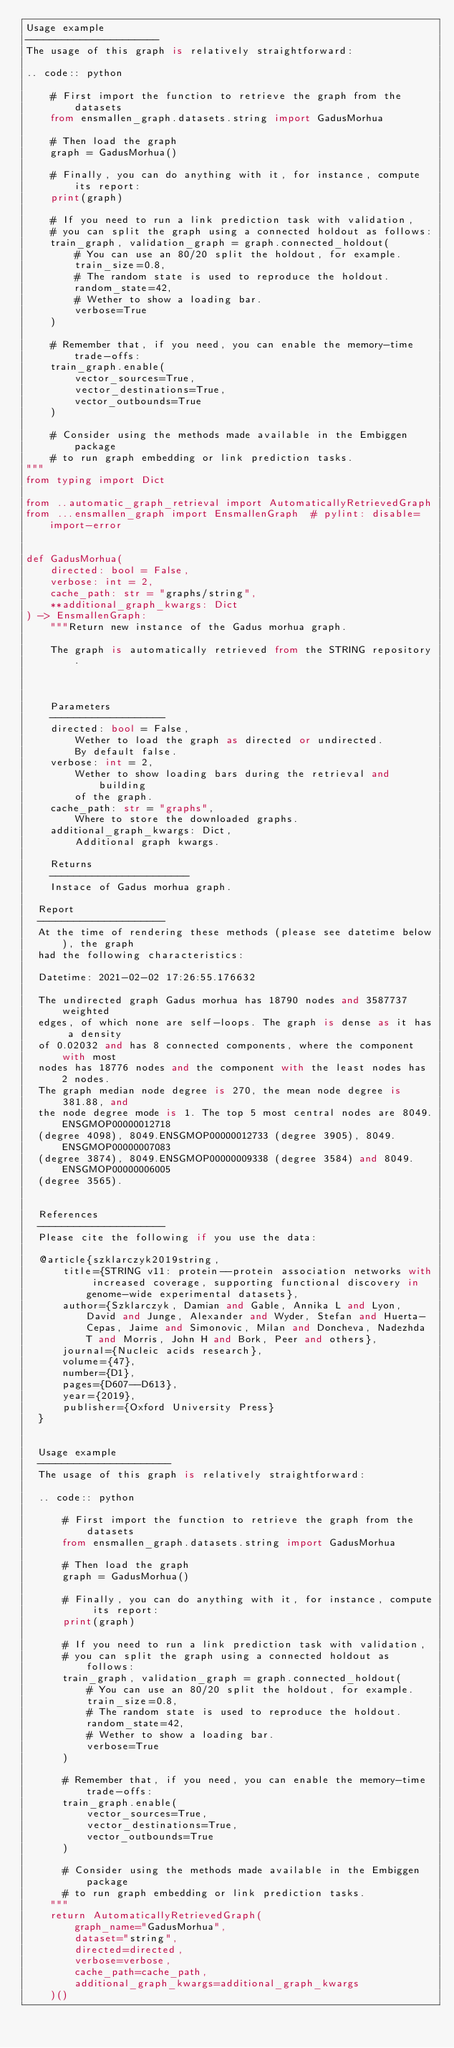Convert code to text. <code><loc_0><loc_0><loc_500><loc_500><_Python_>Usage example
----------------------
The usage of this graph is relatively straightforward:

.. code:: python

    # First import the function to retrieve the graph from the datasets
    from ensmallen_graph.datasets.string import GadusMorhua

    # Then load the graph
    graph = GadusMorhua()

    # Finally, you can do anything with it, for instance, compute its report:
    print(graph)

    # If you need to run a link prediction task with validation,
    # you can split the graph using a connected holdout as follows:
    train_graph, validation_graph = graph.connected_holdout(
        # You can use an 80/20 split the holdout, for example.
        train_size=0.8,
        # The random state is used to reproduce the holdout.
        random_state=42,
        # Wether to show a loading bar.
        verbose=True
    )

    # Remember that, if you need, you can enable the memory-time trade-offs:
    train_graph.enable(
        vector_sources=True,
        vector_destinations=True,
        vector_outbounds=True
    )

    # Consider using the methods made available in the Embiggen package
    # to run graph embedding or link prediction tasks.
"""
from typing import Dict

from ..automatic_graph_retrieval import AutomaticallyRetrievedGraph
from ...ensmallen_graph import EnsmallenGraph  # pylint: disable=import-error


def GadusMorhua(
    directed: bool = False,
    verbose: int = 2,
    cache_path: str = "graphs/string",
    **additional_graph_kwargs: Dict
) -> EnsmallenGraph:
    """Return new instance of the Gadus morhua graph.

    The graph is automatically retrieved from the STRING repository. 

	

    Parameters
    -------------------
    directed: bool = False,
        Wether to load the graph as directed or undirected.
        By default false.
    verbose: int = 2,
        Wether to show loading bars during the retrieval and building
        of the graph.
    cache_path: str = "graphs",
        Where to store the downloaded graphs.
    additional_graph_kwargs: Dict,
        Additional graph kwargs.

    Returns
    -----------------------
    Instace of Gadus morhua graph.

	Report
	---------------------
	At the time of rendering these methods (please see datetime below), the graph
	had the following characteristics:
	
	Datetime: 2021-02-02 17:26:55.176632
	
	The undirected graph Gadus morhua has 18790 nodes and 3587737 weighted
	edges, of which none are self-loops. The graph is dense as it has a density
	of 0.02032 and has 8 connected components, where the component with most
	nodes has 18776 nodes and the component with the least nodes has 2 nodes.
	The graph median node degree is 270, the mean node degree is 381.88, and
	the node degree mode is 1. The top 5 most central nodes are 8049.ENSGMOP00000012718
	(degree 4098), 8049.ENSGMOP00000012733 (degree 3905), 8049.ENSGMOP00000007083
	(degree 3874), 8049.ENSGMOP00000009338 (degree 3584) and 8049.ENSGMOP00000006005
	(degree 3565).
	

	References
	---------------------
	Please cite the following if you use the data:
	
	@article{szklarczyk2019string,
	    title={STRING v11: protein--protein association networks with increased coverage, supporting functional discovery in genome-wide experimental datasets},
	    author={Szklarczyk, Damian and Gable, Annika L and Lyon, David and Junge, Alexander and Wyder, Stefan and Huerta-Cepas, Jaime and Simonovic, Milan and Doncheva, Nadezhda T and Morris, John H and Bork, Peer and others},
	    journal={Nucleic acids research},
	    volume={47},
	    number={D1},
	    pages={D607--D613},
	    year={2019},
	    publisher={Oxford University Press}
	}
	

	Usage example
	----------------------
	The usage of this graph is relatively straightforward:
	
	.. code:: python
	
	    # First import the function to retrieve the graph from the datasets
	    from ensmallen_graph.datasets.string import GadusMorhua
	
	    # Then load the graph
	    graph = GadusMorhua()
	
	    # Finally, you can do anything with it, for instance, compute its report:
	    print(graph)
	
	    # If you need to run a link prediction task with validation,
	    # you can split the graph using a connected holdout as follows:
	    train_graph, validation_graph = graph.connected_holdout(
	        # You can use an 80/20 split the holdout, for example.
	        train_size=0.8,
	        # The random state is used to reproduce the holdout.
	        random_state=42,
	        # Wether to show a loading bar.
	        verbose=True
	    )
	
	    # Remember that, if you need, you can enable the memory-time trade-offs:
	    train_graph.enable(
	        vector_sources=True,
	        vector_destinations=True,
	        vector_outbounds=True
	    )
	
	    # Consider using the methods made available in the Embiggen package
	    # to run graph embedding or link prediction tasks.
    """
    return AutomaticallyRetrievedGraph(
        graph_name="GadusMorhua",
        dataset="string",
        directed=directed,
        verbose=verbose,
        cache_path=cache_path,
        additional_graph_kwargs=additional_graph_kwargs
    )()
</code> 